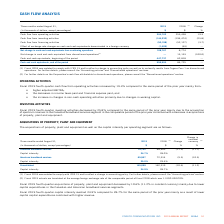According to Cogeco's financial document, What is the rate at which Fiscal 2019 actuals are translated at the average foreign exchange rate of the comparable period of fiscal 2018? According to the financial document, 1.3100 USD/CDN. The relevant text states: "of the comparable period of fiscal 2018 which was 1.3100 USD/CDN...." Also, Why did the Fiscal 2019 fourth-quarter acquisitions of property, plant and equipment decreased? lower capital expenditures in the Canadian and American broadband services segments.. The document states: "y 10.6% (11.2% in constant currency) mainly due to lower capital expenditures in the Canadian and American broadband services segments...." Also, What led to Fiscal 2019 fourth-quarter capital intensity reach 24.9%? lower capital capital expenditures combined with higher revenue.. The document states: "ame period of the prior year mainly as a result of lower capital capital expenditures combined with higher revenue...." Also, can you calculate: What is the increase/ (decrease) Canadian broadband services from 2018 to 2019? Based on the calculation: 79,132-89,405, the result is -10273 (in thousands). This is based on the information: "Canadian broadband services 79,132 89,405 (11.5) (11.7) Canadian broadband services 79,132 89,405 (11.5) (11.7)..." The key data points involved are: 79,132, 89,405. Also, can you calculate: What is the increase/ (decrease) American broadband services from 2018 to 2019? Based on the calculation: 65,967-72,914, the result is -6947 (in thousands). This is based on the information: "American broadband services 65,967 72,914 (9.5) (10.5) American broadband services 65,967 72,914 (9.5) (10.5)..." The key data points involved are: 65,967, 72,914. Also, can you calculate: What is the increase/ (decrease) Consolidated from 2018 to 2019? Based on the calculation: 145,099-162,319, the result is -17220 (in thousands). This is based on the information: "Consolidated 145,099 162,319 (10.6) (11.2) Consolidated 145,099 162,319 (10.6) (11.2)..." The key data points involved are: 145,099, 162,319. 